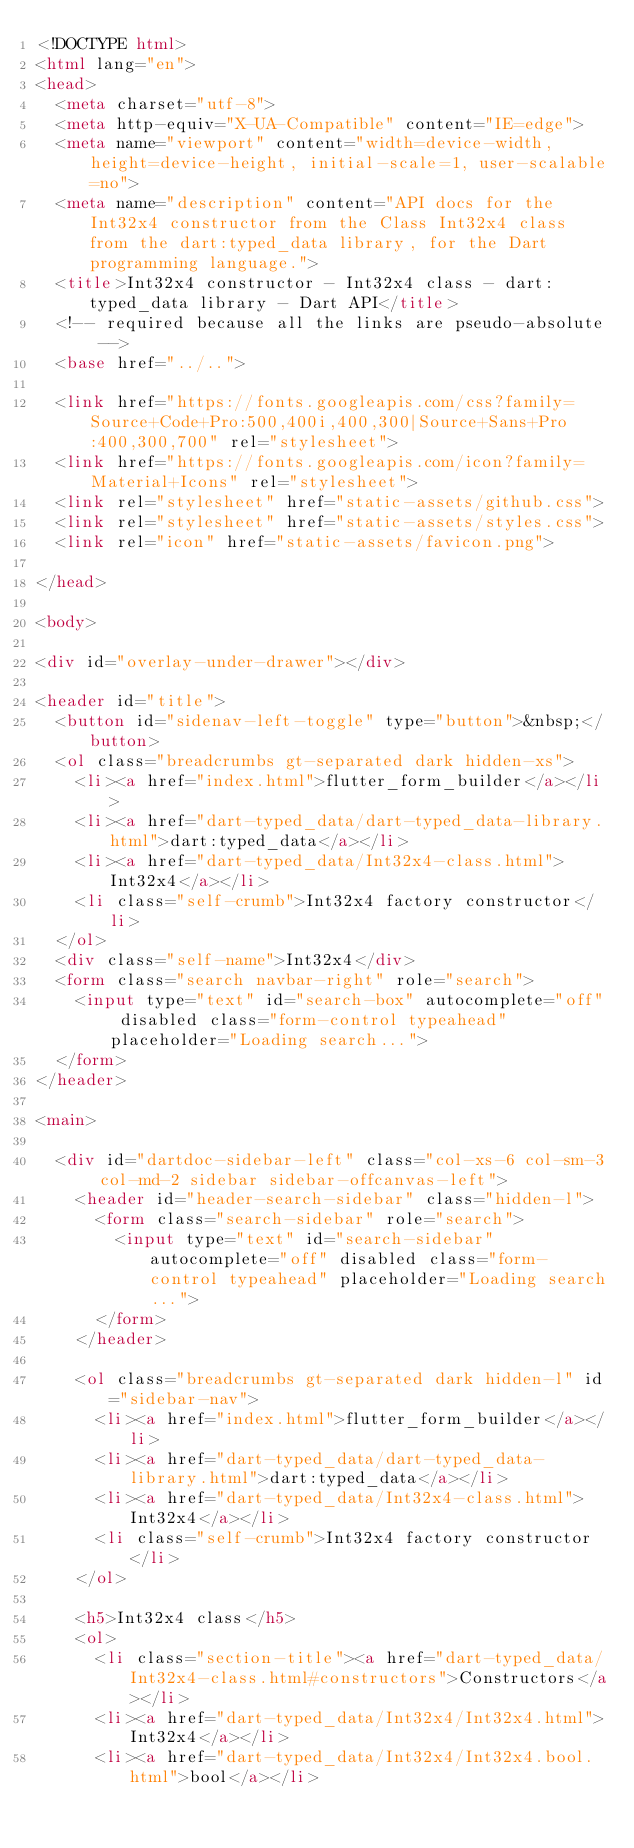<code> <loc_0><loc_0><loc_500><loc_500><_HTML_><!DOCTYPE html>
<html lang="en">
<head>
  <meta charset="utf-8">
  <meta http-equiv="X-UA-Compatible" content="IE=edge">
  <meta name="viewport" content="width=device-width, height=device-height, initial-scale=1, user-scalable=no">
  <meta name="description" content="API docs for the Int32x4 constructor from the Class Int32x4 class from the dart:typed_data library, for the Dart programming language.">
  <title>Int32x4 constructor - Int32x4 class - dart:typed_data library - Dart API</title>
  <!-- required because all the links are pseudo-absolute -->
  <base href="../..">

  <link href="https://fonts.googleapis.com/css?family=Source+Code+Pro:500,400i,400,300|Source+Sans+Pro:400,300,700" rel="stylesheet">
  <link href="https://fonts.googleapis.com/icon?family=Material+Icons" rel="stylesheet">
  <link rel="stylesheet" href="static-assets/github.css">
  <link rel="stylesheet" href="static-assets/styles.css">
  <link rel="icon" href="static-assets/favicon.png">
  
</head>

<body>

<div id="overlay-under-drawer"></div>

<header id="title">
  <button id="sidenav-left-toggle" type="button">&nbsp;</button>
  <ol class="breadcrumbs gt-separated dark hidden-xs">
    <li><a href="index.html">flutter_form_builder</a></li>
    <li><a href="dart-typed_data/dart-typed_data-library.html">dart:typed_data</a></li>
    <li><a href="dart-typed_data/Int32x4-class.html">Int32x4</a></li>
    <li class="self-crumb">Int32x4 factory constructor</li>
  </ol>
  <div class="self-name">Int32x4</div>
  <form class="search navbar-right" role="search">
    <input type="text" id="search-box" autocomplete="off" disabled class="form-control typeahead" placeholder="Loading search...">
  </form>
</header>

<main>

  <div id="dartdoc-sidebar-left" class="col-xs-6 col-sm-3 col-md-2 sidebar sidebar-offcanvas-left">
    <header id="header-search-sidebar" class="hidden-l">
      <form class="search-sidebar" role="search">
        <input type="text" id="search-sidebar" autocomplete="off" disabled class="form-control typeahead" placeholder="Loading search...">
      </form>
    </header>
    
    <ol class="breadcrumbs gt-separated dark hidden-l" id="sidebar-nav">
      <li><a href="index.html">flutter_form_builder</a></li>
      <li><a href="dart-typed_data/dart-typed_data-library.html">dart:typed_data</a></li>
      <li><a href="dart-typed_data/Int32x4-class.html">Int32x4</a></li>
      <li class="self-crumb">Int32x4 factory constructor</li>
    </ol>
    
    <h5>Int32x4 class</h5>
    <ol>
      <li class="section-title"><a href="dart-typed_data/Int32x4-class.html#constructors">Constructors</a></li>
      <li><a href="dart-typed_data/Int32x4/Int32x4.html">Int32x4</a></li>
      <li><a href="dart-typed_data/Int32x4/Int32x4.bool.html">bool</a></li></code> 